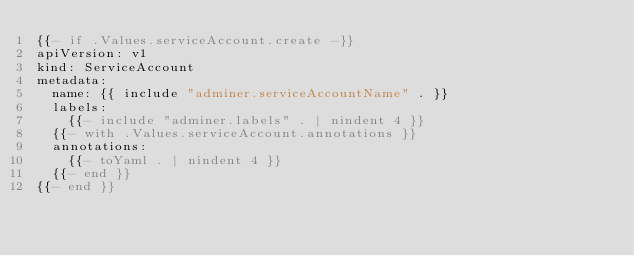Convert code to text. <code><loc_0><loc_0><loc_500><loc_500><_YAML_>{{- if .Values.serviceAccount.create -}}
apiVersion: v1
kind: ServiceAccount
metadata:
  name: {{ include "adminer.serviceAccountName" . }}
  labels:
    {{- include "adminer.labels" . | nindent 4 }}
  {{- with .Values.serviceAccount.annotations }}
  annotations:
    {{- toYaml . | nindent 4 }}
  {{- end }}
{{- end }}
</code> 